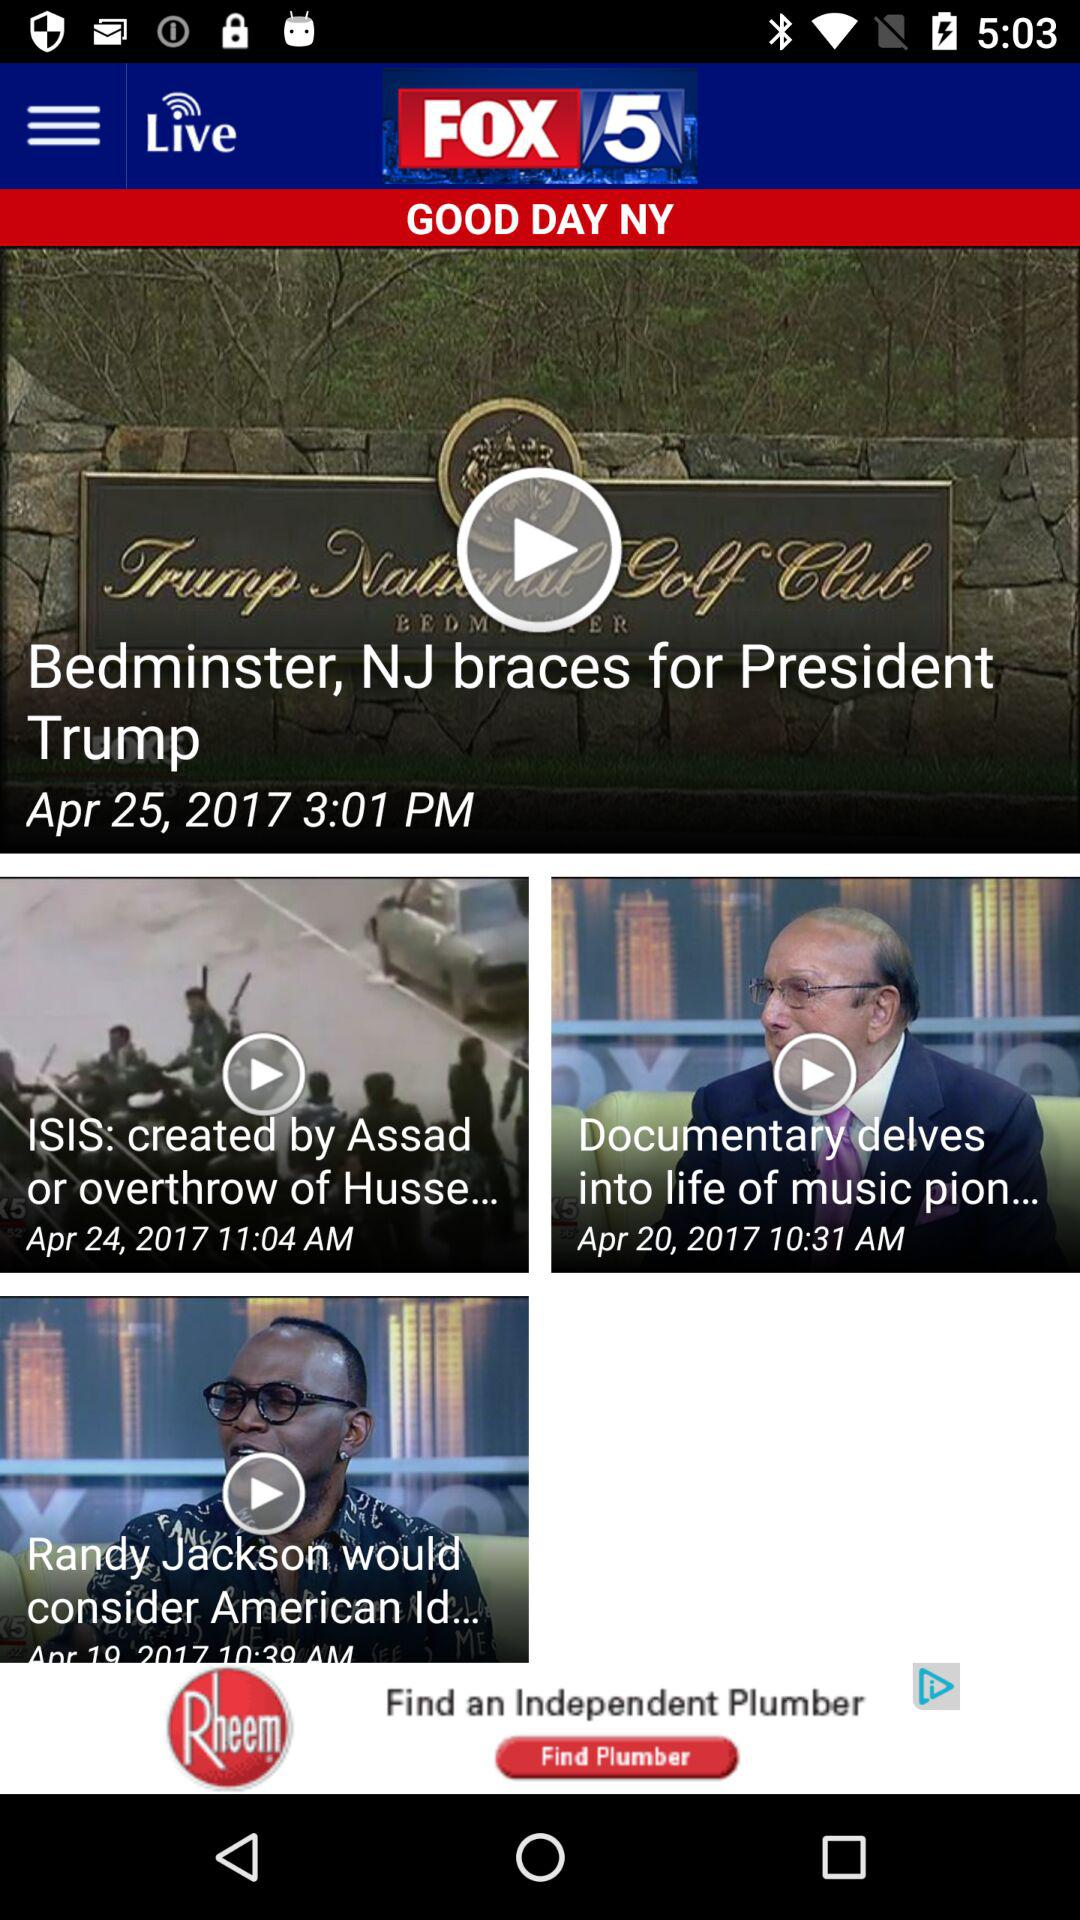What is the news agency name? The news agency name is "FOX 5". 